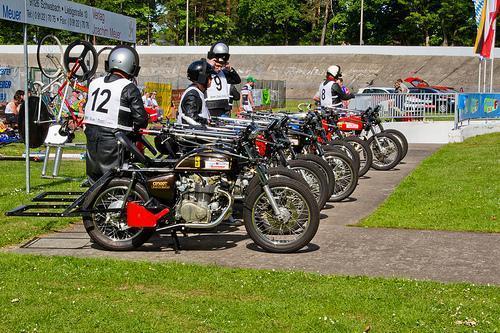How many motorcycles are in this line?
Give a very brief answer. 10. 